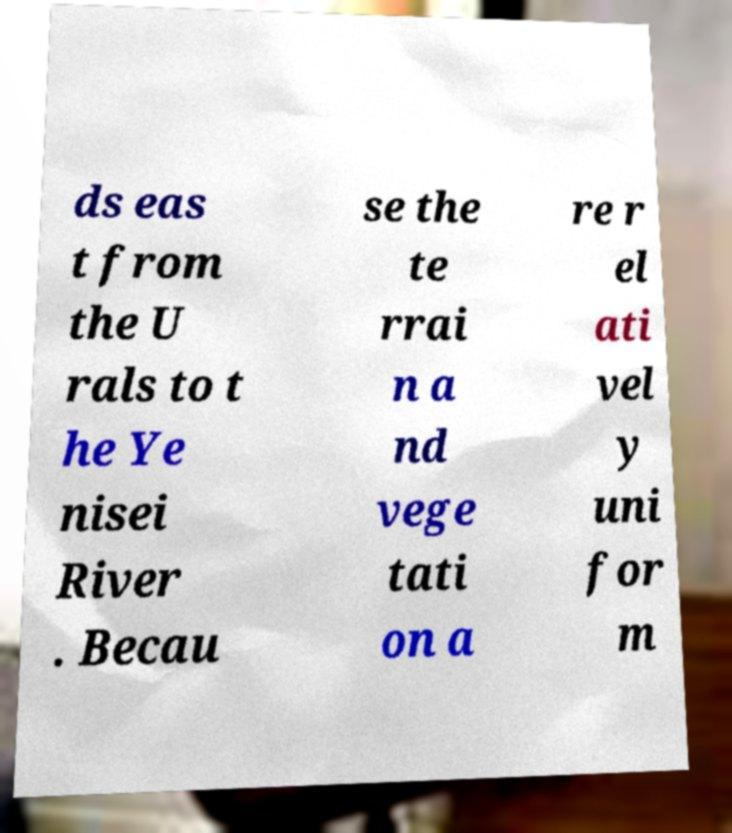Can you accurately transcribe the text from the provided image for me? ds eas t from the U rals to t he Ye nisei River . Becau se the te rrai n a nd vege tati on a re r el ati vel y uni for m 